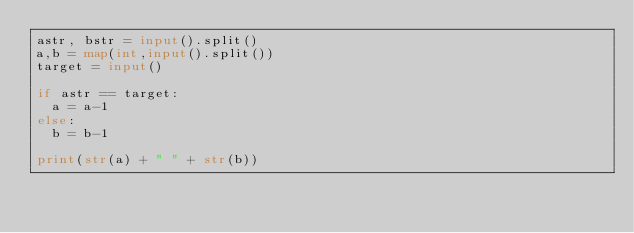Convert code to text. <code><loc_0><loc_0><loc_500><loc_500><_Python_>astr, bstr = input().split()
a,b = map(int,input().split())
target = input()

if astr == target:
  a = a-1
else:
  b = b-1

print(str(a) + " " + str(b))</code> 